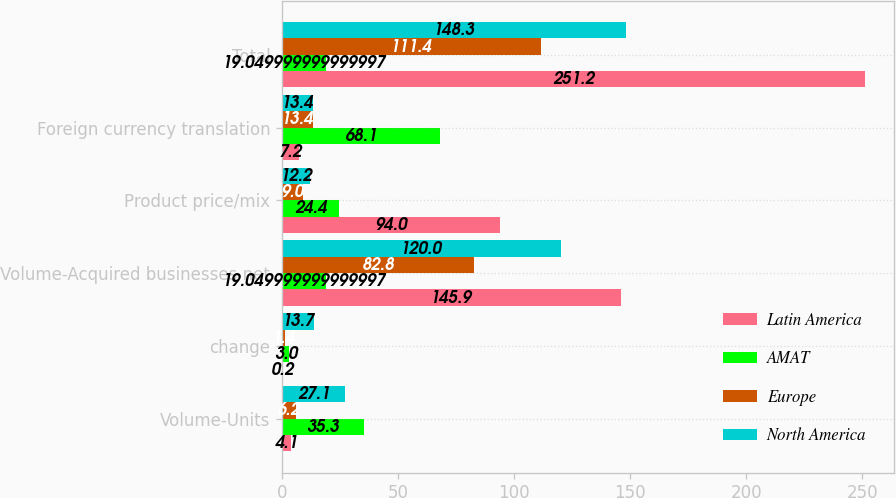Convert chart. <chart><loc_0><loc_0><loc_500><loc_500><stacked_bar_chart><ecel><fcel>Volume-Units<fcel>change<fcel>Volume-Acquired businesses net<fcel>Product price/mix<fcel>Foreign currency translation<fcel>Total<nl><fcel>Latin America<fcel>4.1<fcel>0.2<fcel>145.9<fcel>94<fcel>7.2<fcel>251.2<nl><fcel>AMAT<fcel>35.3<fcel>3<fcel>19.05<fcel>24.4<fcel>68.1<fcel>19.05<nl><fcel>Europe<fcel>6.2<fcel>1.4<fcel>82.8<fcel>9<fcel>13.4<fcel>111.4<nl><fcel>North America<fcel>27.1<fcel>13.7<fcel>120<fcel>12.2<fcel>13.4<fcel>148.3<nl></chart> 